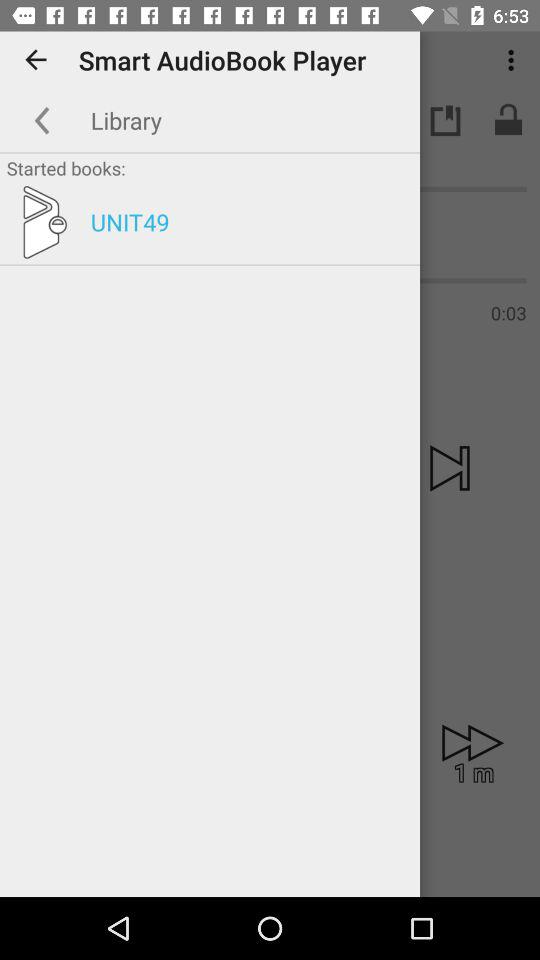What is the name of the application? The name of the application is "Smart AudioBook Player". 